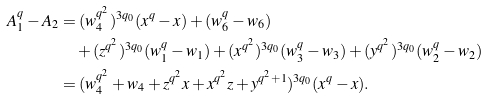Convert formula to latex. <formula><loc_0><loc_0><loc_500><loc_500>A _ { 1 } ^ { q } - A _ { 2 } & = ( w _ { 4 } ^ { q ^ { 2 } } ) ^ { 3 q _ { 0 } } ( x ^ { q } - x ) + ( w _ { 6 } ^ { q } - w _ { 6 } ) \\ & \quad + ( z ^ { q ^ { 2 } } ) ^ { 3 q _ { 0 } } ( w _ { 1 } ^ { q } - w _ { 1 } ) + ( x ^ { q ^ { 2 } } ) ^ { 3 q _ { 0 } } ( w _ { 3 } ^ { q } - w _ { 3 } ) + ( y ^ { q ^ { 2 } } ) ^ { 3 q _ { 0 } } ( w _ { 2 } ^ { q } - w _ { 2 } ) \\ & = ( w _ { 4 } ^ { q ^ { 2 } } + w _ { 4 } + z ^ { q ^ { 2 } } x + x ^ { q ^ { 2 } } z + y ^ { q ^ { 2 } + 1 } ) ^ { 3 q _ { 0 } } ( x ^ { q } - x ) .</formula> 